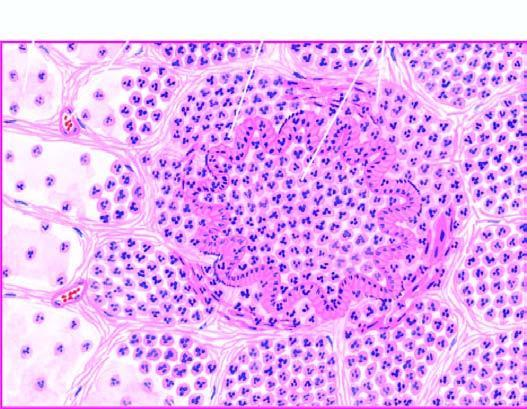re the bronchioles as well as the adjacent alveoli filled with exudate consisting chiefly of neutrophils?
Answer the question using a single word or phrase. Yes 